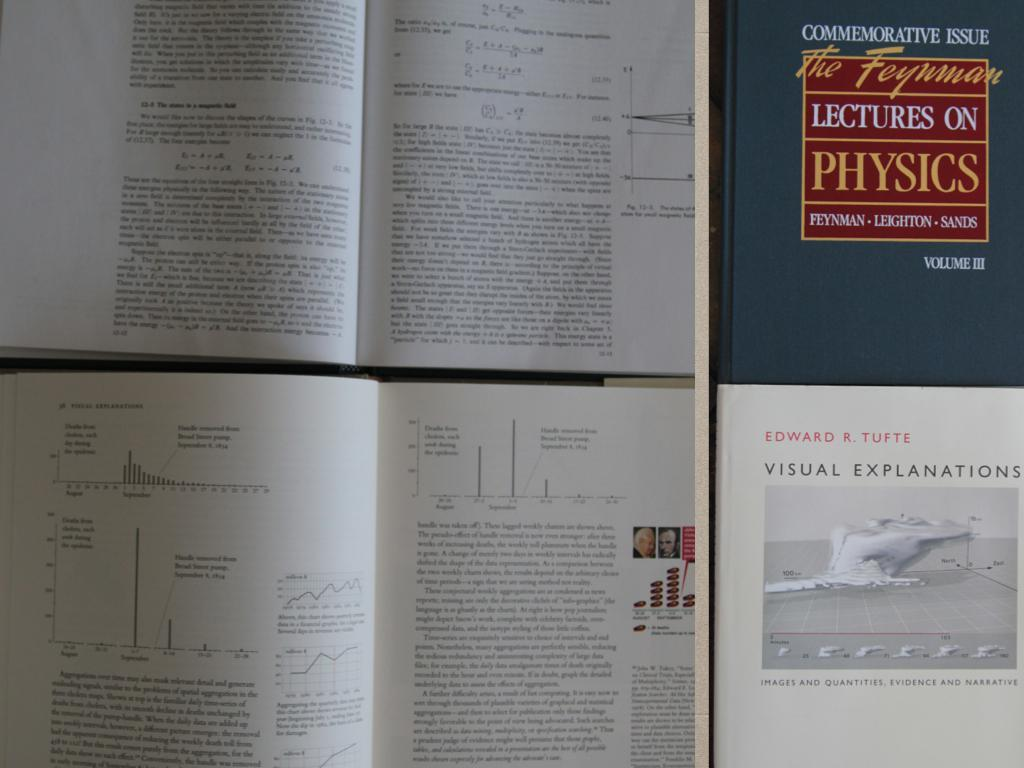What objects are present in the image? There are books in the image. Can you describe the books in more detail? There is something written on the books. What flavor of ice cream does the monkey enjoy in the image? There is no monkey or ice cream present in the image, so it is not possible to answer that question. 